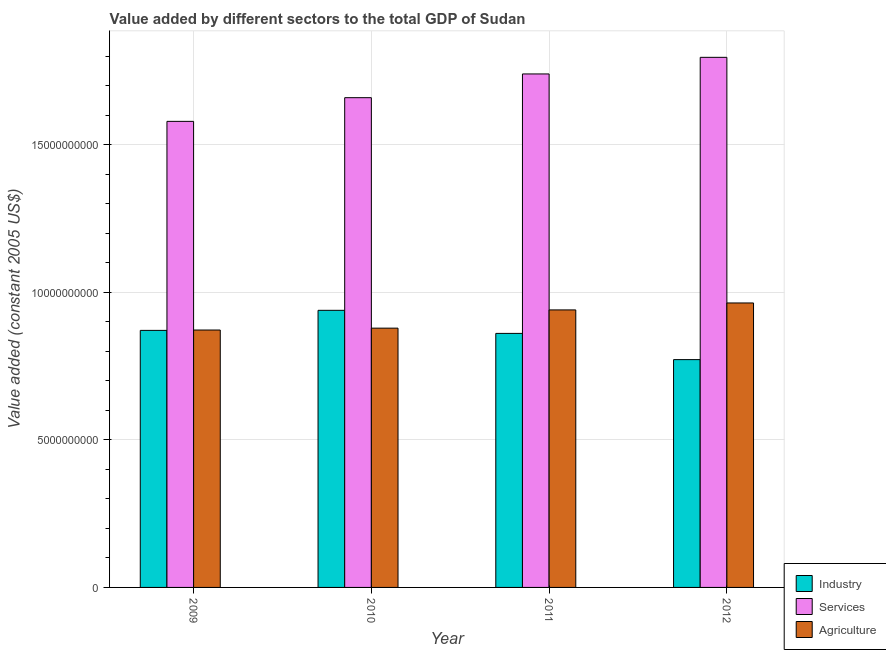How many different coloured bars are there?
Your answer should be compact. 3. Are the number of bars per tick equal to the number of legend labels?
Your answer should be very brief. Yes. Are the number of bars on each tick of the X-axis equal?
Make the answer very short. Yes. How many bars are there on the 1st tick from the left?
Offer a very short reply. 3. In how many cases, is the number of bars for a given year not equal to the number of legend labels?
Provide a short and direct response. 0. What is the value added by services in 2011?
Your answer should be compact. 1.74e+1. Across all years, what is the maximum value added by agricultural sector?
Offer a terse response. 9.64e+09. Across all years, what is the minimum value added by services?
Provide a succinct answer. 1.58e+1. In which year was the value added by agricultural sector maximum?
Offer a very short reply. 2012. What is the total value added by industrial sector in the graph?
Offer a terse response. 3.44e+1. What is the difference between the value added by agricultural sector in 2009 and that in 2011?
Make the answer very short. -6.81e+08. What is the difference between the value added by industrial sector in 2010 and the value added by agricultural sector in 2009?
Make the answer very short. 6.80e+08. What is the average value added by industrial sector per year?
Keep it short and to the point. 8.61e+09. In the year 2010, what is the difference between the value added by agricultural sector and value added by industrial sector?
Your response must be concise. 0. What is the ratio of the value added by industrial sector in 2009 to that in 2010?
Ensure brevity in your answer.  0.93. Is the value added by industrial sector in 2010 less than that in 2011?
Give a very brief answer. No. Is the difference between the value added by industrial sector in 2011 and 2012 greater than the difference between the value added by services in 2011 and 2012?
Provide a succinct answer. No. What is the difference between the highest and the second highest value added by industrial sector?
Give a very brief answer. 6.80e+08. What is the difference between the highest and the lowest value added by agricultural sector?
Your answer should be very brief. 9.17e+08. Is the sum of the value added by agricultural sector in 2009 and 2012 greater than the maximum value added by industrial sector across all years?
Provide a succinct answer. Yes. What does the 1st bar from the left in 2011 represents?
Provide a short and direct response. Industry. What does the 3rd bar from the right in 2010 represents?
Keep it short and to the point. Industry. How many years are there in the graph?
Keep it short and to the point. 4. Are the values on the major ticks of Y-axis written in scientific E-notation?
Offer a terse response. No. Does the graph contain grids?
Ensure brevity in your answer.  Yes. What is the title of the graph?
Provide a short and direct response. Value added by different sectors to the total GDP of Sudan. Does "Gaseous fuel" appear as one of the legend labels in the graph?
Provide a succinct answer. No. What is the label or title of the X-axis?
Your answer should be very brief. Year. What is the label or title of the Y-axis?
Ensure brevity in your answer.  Value added (constant 2005 US$). What is the Value added (constant 2005 US$) of Industry in 2009?
Make the answer very short. 8.71e+09. What is the Value added (constant 2005 US$) of Services in 2009?
Offer a very short reply. 1.58e+1. What is the Value added (constant 2005 US$) of Agriculture in 2009?
Your answer should be very brief. 8.72e+09. What is the Value added (constant 2005 US$) in Industry in 2010?
Your answer should be compact. 9.39e+09. What is the Value added (constant 2005 US$) in Services in 2010?
Make the answer very short. 1.66e+1. What is the Value added (constant 2005 US$) of Agriculture in 2010?
Give a very brief answer. 8.79e+09. What is the Value added (constant 2005 US$) of Industry in 2011?
Your answer should be very brief. 8.61e+09. What is the Value added (constant 2005 US$) of Services in 2011?
Your answer should be compact. 1.74e+1. What is the Value added (constant 2005 US$) in Agriculture in 2011?
Provide a short and direct response. 9.41e+09. What is the Value added (constant 2005 US$) of Industry in 2012?
Provide a short and direct response. 7.72e+09. What is the Value added (constant 2005 US$) in Services in 2012?
Ensure brevity in your answer.  1.80e+1. What is the Value added (constant 2005 US$) in Agriculture in 2012?
Your answer should be compact. 9.64e+09. Across all years, what is the maximum Value added (constant 2005 US$) of Industry?
Your answer should be very brief. 9.39e+09. Across all years, what is the maximum Value added (constant 2005 US$) of Services?
Give a very brief answer. 1.80e+1. Across all years, what is the maximum Value added (constant 2005 US$) in Agriculture?
Give a very brief answer. 9.64e+09. Across all years, what is the minimum Value added (constant 2005 US$) in Industry?
Make the answer very short. 7.72e+09. Across all years, what is the minimum Value added (constant 2005 US$) of Services?
Make the answer very short. 1.58e+1. Across all years, what is the minimum Value added (constant 2005 US$) of Agriculture?
Ensure brevity in your answer.  8.72e+09. What is the total Value added (constant 2005 US$) of Industry in the graph?
Provide a short and direct response. 3.44e+1. What is the total Value added (constant 2005 US$) in Services in the graph?
Your answer should be very brief. 6.78e+1. What is the total Value added (constant 2005 US$) of Agriculture in the graph?
Provide a short and direct response. 3.66e+1. What is the difference between the Value added (constant 2005 US$) of Industry in 2009 and that in 2010?
Make the answer very short. -6.80e+08. What is the difference between the Value added (constant 2005 US$) of Services in 2009 and that in 2010?
Your answer should be compact. -8.03e+08. What is the difference between the Value added (constant 2005 US$) of Agriculture in 2009 and that in 2010?
Your answer should be compact. -6.31e+07. What is the difference between the Value added (constant 2005 US$) of Industry in 2009 and that in 2011?
Provide a short and direct response. 1.02e+08. What is the difference between the Value added (constant 2005 US$) of Services in 2009 and that in 2011?
Your answer should be compact. -1.61e+09. What is the difference between the Value added (constant 2005 US$) in Agriculture in 2009 and that in 2011?
Your answer should be very brief. -6.81e+08. What is the difference between the Value added (constant 2005 US$) in Industry in 2009 and that in 2012?
Your answer should be compact. 9.91e+08. What is the difference between the Value added (constant 2005 US$) of Services in 2009 and that in 2012?
Give a very brief answer. -2.17e+09. What is the difference between the Value added (constant 2005 US$) of Agriculture in 2009 and that in 2012?
Keep it short and to the point. -9.17e+08. What is the difference between the Value added (constant 2005 US$) in Industry in 2010 and that in 2011?
Keep it short and to the point. 7.82e+08. What is the difference between the Value added (constant 2005 US$) of Services in 2010 and that in 2011?
Your answer should be very brief. -8.04e+08. What is the difference between the Value added (constant 2005 US$) of Agriculture in 2010 and that in 2011?
Offer a terse response. -6.18e+08. What is the difference between the Value added (constant 2005 US$) in Industry in 2010 and that in 2012?
Your answer should be very brief. 1.67e+09. What is the difference between the Value added (constant 2005 US$) in Services in 2010 and that in 2012?
Give a very brief answer. -1.37e+09. What is the difference between the Value added (constant 2005 US$) of Agriculture in 2010 and that in 2012?
Your response must be concise. -8.54e+08. What is the difference between the Value added (constant 2005 US$) in Industry in 2011 and that in 2012?
Ensure brevity in your answer.  8.89e+08. What is the difference between the Value added (constant 2005 US$) in Services in 2011 and that in 2012?
Keep it short and to the point. -5.63e+08. What is the difference between the Value added (constant 2005 US$) in Agriculture in 2011 and that in 2012?
Provide a short and direct response. -2.36e+08. What is the difference between the Value added (constant 2005 US$) of Industry in 2009 and the Value added (constant 2005 US$) of Services in 2010?
Ensure brevity in your answer.  -7.89e+09. What is the difference between the Value added (constant 2005 US$) in Industry in 2009 and the Value added (constant 2005 US$) in Agriculture in 2010?
Offer a terse response. -7.57e+07. What is the difference between the Value added (constant 2005 US$) of Services in 2009 and the Value added (constant 2005 US$) of Agriculture in 2010?
Provide a short and direct response. 7.01e+09. What is the difference between the Value added (constant 2005 US$) in Industry in 2009 and the Value added (constant 2005 US$) in Services in 2011?
Offer a very short reply. -8.69e+09. What is the difference between the Value added (constant 2005 US$) of Industry in 2009 and the Value added (constant 2005 US$) of Agriculture in 2011?
Keep it short and to the point. -6.94e+08. What is the difference between the Value added (constant 2005 US$) of Services in 2009 and the Value added (constant 2005 US$) of Agriculture in 2011?
Offer a terse response. 6.39e+09. What is the difference between the Value added (constant 2005 US$) of Industry in 2009 and the Value added (constant 2005 US$) of Services in 2012?
Ensure brevity in your answer.  -9.25e+09. What is the difference between the Value added (constant 2005 US$) in Industry in 2009 and the Value added (constant 2005 US$) in Agriculture in 2012?
Offer a terse response. -9.30e+08. What is the difference between the Value added (constant 2005 US$) in Services in 2009 and the Value added (constant 2005 US$) in Agriculture in 2012?
Keep it short and to the point. 6.15e+09. What is the difference between the Value added (constant 2005 US$) in Industry in 2010 and the Value added (constant 2005 US$) in Services in 2011?
Keep it short and to the point. -8.01e+09. What is the difference between the Value added (constant 2005 US$) in Industry in 2010 and the Value added (constant 2005 US$) in Agriculture in 2011?
Provide a short and direct response. -1.40e+07. What is the difference between the Value added (constant 2005 US$) in Services in 2010 and the Value added (constant 2005 US$) in Agriculture in 2011?
Offer a terse response. 7.19e+09. What is the difference between the Value added (constant 2005 US$) in Industry in 2010 and the Value added (constant 2005 US$) in Services in 2012?
Keep it short and to the point. -8.57e+09. What is the difference between the Value added (constant 2005 US$) in Industry in 2010 and the Value added (constant 2005 US$) in Agriculture in 2012?
Ensure brevity in your answer.  -2.50e+08. What is the difference between the Value added (constant 2005 US$) of Services in 2010 and the Value added (constant 2005 US$) of Agriculture in 2012?
Your response must be concise. 6.96e+09. What is the difference between the Value added (constant 2005 US$) of Industry in 2011 and the Value added (constant 2005 US$) of Services in 2012?
Make the answer very short. -9.36e+09. What is the difference between the Value added (constant 2005 US$) of Industry in 2011 and the Value added (constant 2005 US$) of Agriculture in 2012?
Your response must be concise. -1.03e+09. What is the difference between the Value added (constant 2005 US$) in Services in 2011 and the Value added (constant 2005 US$) in Agriculture in 2012?
Ensure brevity in your answer.  7.76e+09. What is the average Value added (constant 2005 US$) of Industry per year?
Make the answer very short. 8.61e+09. What is the average Value added (constant 2005 US$) of Services per year?
Offer a very short reply. 1.69e+1. What is the average Value added (constant 2005 US$) in Agriculture per year?
Ensure brevity in your answer.  9.14e+09. In the year 2009, what is the difference between the Value added (constant 2005 US$) of Industry and Value added (constant 2005 US$) of Services?
Make the answer very short. -7.08e+09. In the year 2009, what is the difference between the Value added (constant 2005 US$) in Industry and Value added (constant 2005 US$) in Agriculture?
Offer a terse response. -1.25e+07. In the year 2009, what is the difference between the Value added (constant 2005 US$) in Services and Value added (constant 2005 US$) in Agriculture?
Provide a short and direct response. 7.07e+09. In the year 2010, what is the difference between the Value added (constant 2005 US$) in Industry and Value added (constant 2005 US$) in Services?
Ensure brevity in your answer.  -7.21e+09. In the year 2010, what is the difference between the Value added (constant 2005 US$) of Industry and Value added (constant 2005 US$) of Agriculture?
Provide a succinct answer. 6.04e+08. In the year 2010, what is the difference between the Value added (constant 2005 US$) in Services and Value added (constant 2005 US$) in Agriculture?
Give a very brief answer. 7.81e+09. In the year 2011, what is the difference between the Value added (constant 2005 US$) in Industry and Value added (constant 2005 US$) in Services?
Ensure brevity in your answer.  -8.79e+09. In the year 2011, what is the difference between the Value added (constant 2005 US$) in Industry and Value added (constant 2005 US$) in Agriculture?
Keep it short and to the point. -7.96e+08. In the year 2011, what is the difference between the Value added (constant 2005 US$) in Services and Value added (constant 2005 US$) in Agriculture?
Your response must be concise. 8.00e+09. In the year 2012, what is the difference between the Value added (constant 2005 US$) of Industry and Value added (constant 2005 US$) of Services?
Provide a succinct answer. -1.02e+1. In the year 2012, what is the difference between the Value added (constant 2005 US$) in Industry and Value added (constant 2005 US$) in Agriculture?
Your answer should be compact. -1.92e+09. In the year 2012, what is the difference between the Value added (constant 2005 US$) of Services and Value added (constant 2005 US$) of Agriculture?
Provide a short and direct response. 8.32e+09. What is the ratio of the Value added (constant 2005 US$) of Industry in 2009 to that in 2010?
Keep it short and to the point. 0.93. What is the ratio of the Value added (constant 2005 US$) of Services in 2009 to that in 2010?
Your answer should be very brief. 0.95. What is the ratio of the Value added (constant 2005 US$) in Industry in 2009 to that in 2011?
Your answer should be very brief. 1.01. What is the ratio of the Value added (constant 2005 US$) of Services in 2009 to that in 2011?
Offer a very short reply. 0.91. What is the ratio of the Value added (constant 2005 US$) in Agriculture in 2009 to that in 2011?
Offer a terse response. 0.93. What is the ratio of the Value added (constant 2005 US$) in Industry in 2009 to that in 2012?
Keep it short and to the point. 1.13. What is the ratio of the Value added (constant 2005 US$) in Services in 2009 to that in 2012?
Your answer should be compact. 0.88. What is the ratio of the Value added (constant 2005 US$) of Agriculture in 2009 to that in 2012?
Offer a terse response. 0.9. What is the ratio of the Value added (constant 2005 US$) in Industry in 2010 to that in 2011?
Offer a terse response. 1.09. What is the ratio of the Value added (constant 2005 US$) of Services in 2010 to that in 2011?
Give a very brief answer. 0.95. What is the ratio of the Value added (constant 2005 US$) of Agriculture in 2010 to that in 2011?
Provide a short and direct response. 0.93. What is the ratio of the Value added (constant 2005 US$) of Industry in 2010 to that in 2012?
Keep it short and to the point. 1.22. What is the ratio of the Value added (constant 2005 US$) of Services in 2010 to that in 2012?
Offer a very short reply. 0.92. What is the ratio of the Value added (constant 2005 US$) in Agriculture in 2010 to that in 2012?
Your answer should be very brief. 0.91. What is the ratio of the Value added (constant 2005 US$) in Industry in 2011 to that in 2012?
Ensure brevity in your answer.  1.12. What is the ratio of the Value added (constant 2005 US$) in Services in 2011 to that in 2012?
Offer a very short reply. 0.97. What is the ratio of the Value added (constant 2005 US$) in Agriculture in 2011 to that in 2012?
Your response must be concise. 0.98. What is the difference between the highest and the second highest Value added (constant 2005 US$) of Industry?
Ensure brevity in your answer.  6.80e+08. What is the difference between the highest and the second highest Value added (constant 2005 US$) of Services?
Give a very brief answer. 5.63e+08. What is the difference between the highest and the second highest Value added (constant 2005 US$) in Agriculture?
Provide a succinct answer. 2.36e+08. What is the difference between the highest and the lowest Value added (constant 2005 US$) of Industry?
Offer a terse response. 1.67e+09. What is the difference between the highest and the lowest Value added (constant 2005 US$) in Services?
Make the answer very short. 2.17e+09. What is the difference between the highest and the lowest Value added (constant 2005 US$) of Agriculture?
Your answer should be compact. 9.17e+08. 